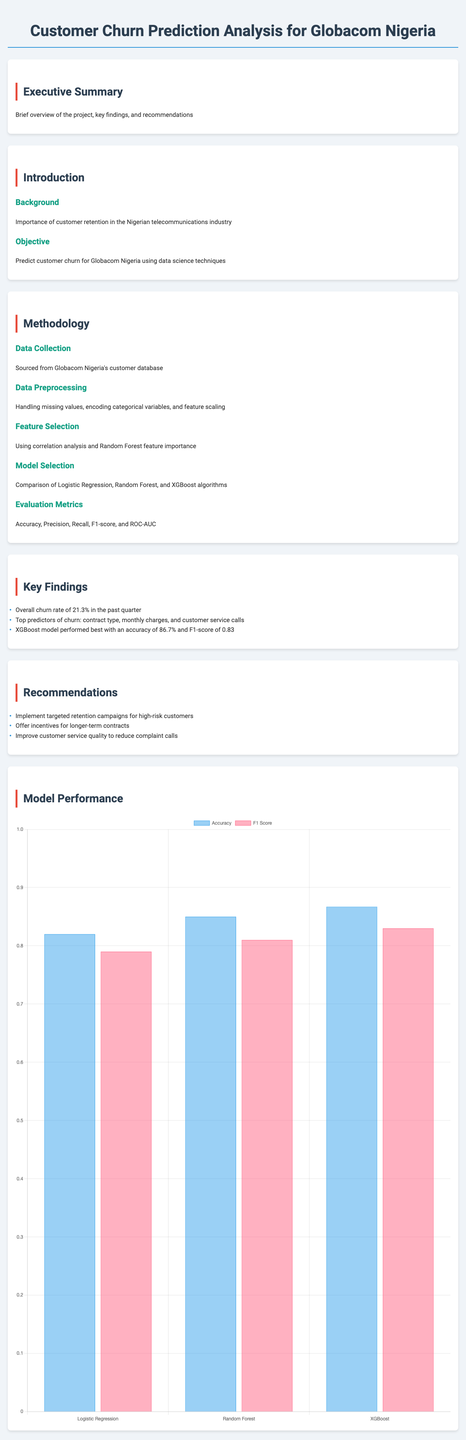what is the overall churn rate? The overall churn rate is stated in the key findings section of the report, which indicates the percentage of customers that have churned in the past quarter.
Answer: 21.3% who is the primary source of data? The primary source of data is mentioned in the data sources section of the report, specifically referring to where the customer data was sourced from.
Answer: Globacom Nigeria customer database what model performed best in the analysis? The best-performing model is identified in the key findings section, which compares different models and their accuracies.
Answer: XGBoost what is the accuracy of the Random Forest model? The accuracy of the Random Forest model is specified in the model performance section, showing its effectiveness compared to other models.
Answer: 85% which customer segment is most likely to churn? The report contains insights on customer segments, specifically identifying which category is more at risk of churning.
Answer: Young urban professionals what is a recommended strategy for reducing churn? The recommendations section outlines strategies to address customer churn, mentioning specific actions to take for retention.
Answer: Implement targeted retention campaigns which programming language was used for the analysis? The tools used section reveals the programming language that was predominantly utilized during the data analysis process.
Answer: Python 3.8 what is one future work direction mentioned? In the future work section, potential directions for further development are discussed, highlighting one of the suggested areas for improvement.
Answer: Incorporate real-time data streaming for dynamic churn prediction 